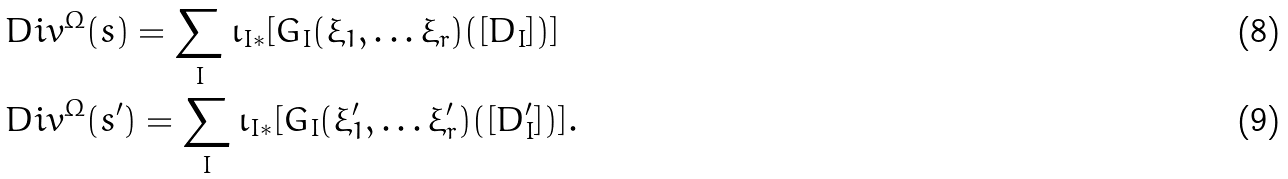Convert formula to latex. <formula><loc_0><loc_0><loc_500><loc_500>& \ D i v ^ { \Omega } ( s ) = \sum _ { I } \iota _ { I * } [ G _ { I } ( \xi _ { 1 } , \dots \xi _ { r } ) ( [ D _ { I } ] ) ] \\ & \ D i v ^ { \Omega } ( s ^ { \prime } ) = \sum _ { I } \iota _ { I * } [ G _ { I } ( \xi ^ { \prime } _ { 1 } , \dots \xi ^ { \prime } _ { r } ) ( [ D ^ { \prime } _ { I } ] ) ] .</formula> 